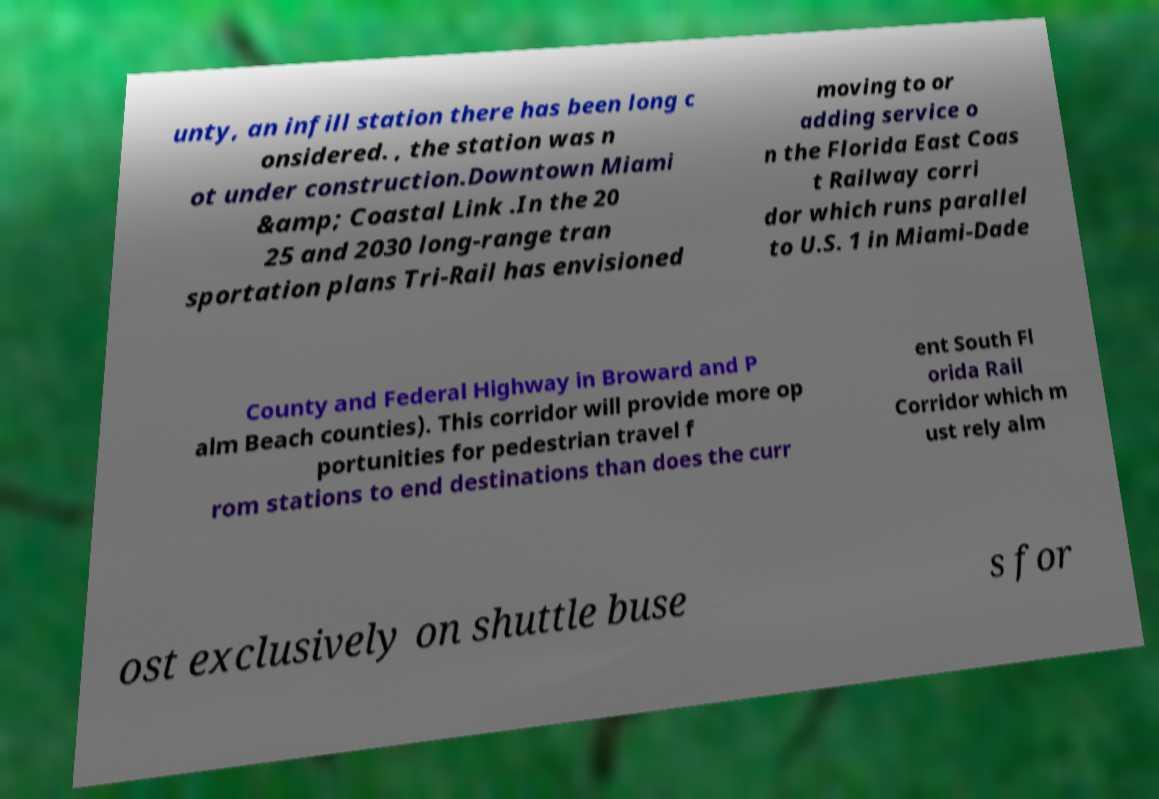Please identify and transcribe the text found in this image. unty, an infill station there has been long c onsidered. , the station was n ot under construction.Downtown Miami &amp; Coastal Link .In the 20 25 and 2030 long-range tran sportation plans Tri-Rail has envisioned moving to or adding service o n the Florida East Coas t Railway corri dor which runs parallel to U.S. 1 in Miami-Dade County and Federal Highway in Broward and P alm Beach counties). This corridor will provide more op portunities for pedestrian travel f rom stations to end destinations than does the curr ent South Fl orida Rail Corridor which m ust rely alm ost exclusively on shuttle buse s for 